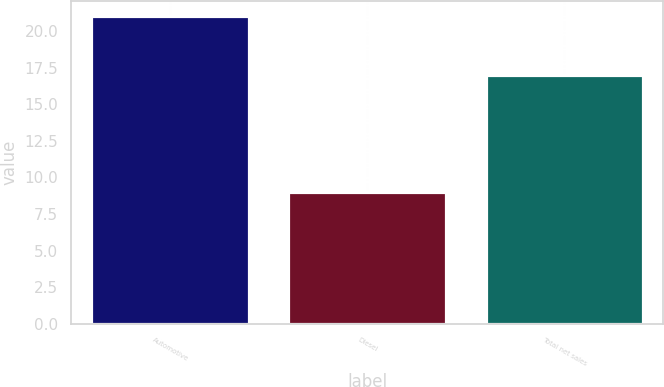<chart> <loc_0><loc_0><loc_500><loc_500><bar_chart><fcel>Automotive<fcel>Diesel<fcel>Total net sales<nl><fcel>21<fcel>9<fcel>17<nl></chart> 